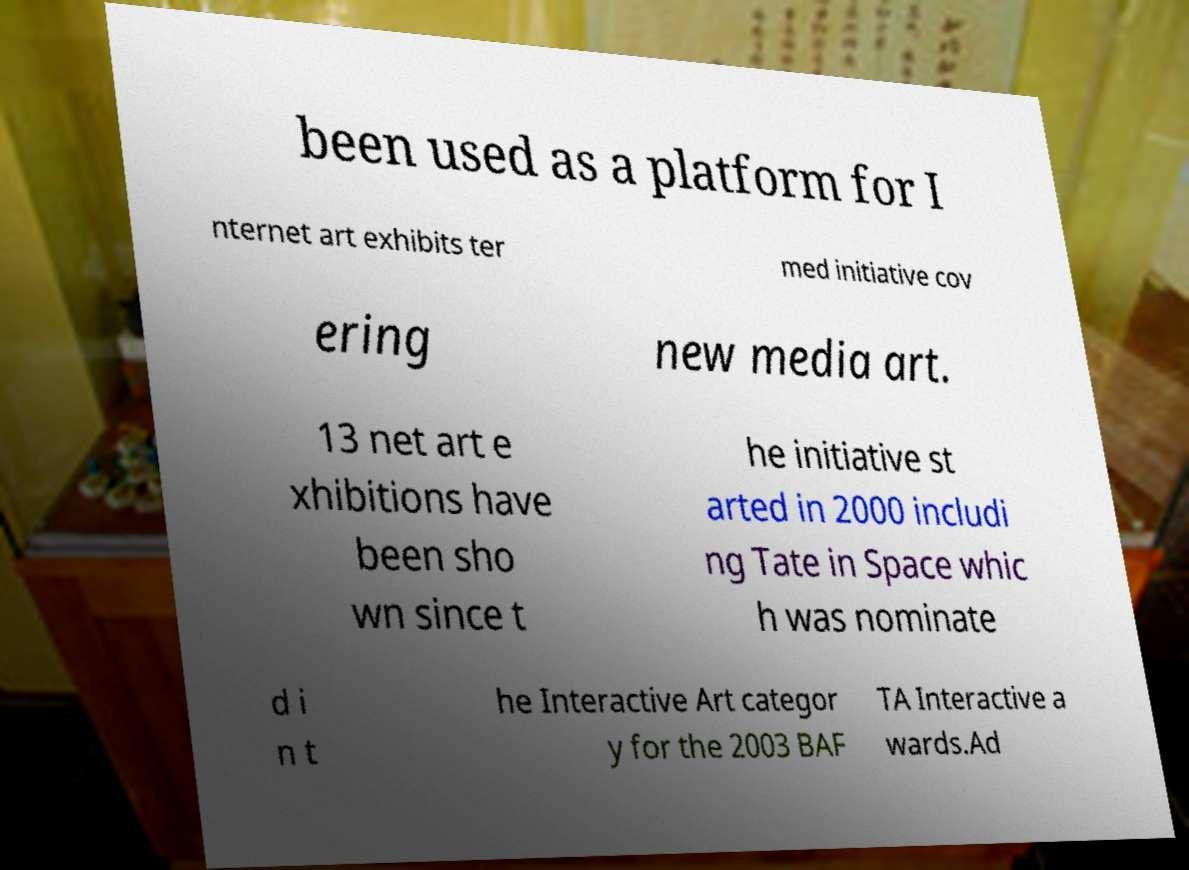For documentation purposes, I need the text within this image transcribed. Could you provide that? been used as a platform for I nternet art exhibits ter med initiative cov ering new media art. 13 net art e xhibitions have been sho wn since t he initiative st arted in 2000 includi ng Tate in Space whic h was nominate d i n t he Interactive Art categor y for the 2003 BAF TA Interactive a wards.Ad 